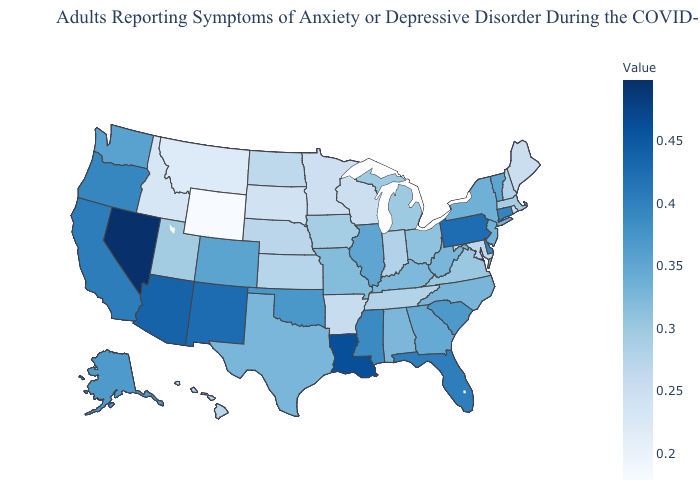Does Nevada have the highest value in the USA?
Concise answer only. Yes. Is the legend a continuous bar?
Short answer required. Yes. Does Pennsylvania have the highest value in the Northeast?
Write a very short answer. Yes. Which states have the lowest value in the USA?
Answer briefly. Wyoming. Is the legend a continuous bar?
Be succinct. Yes. Does the map have missing data?
Concise answer only. No. 